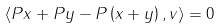<formula> <loc_0><loc_0><loc_500><loc_500>\langle P x + P y - P \left ( x + y \right ) , v \rangle = 0</formula> 